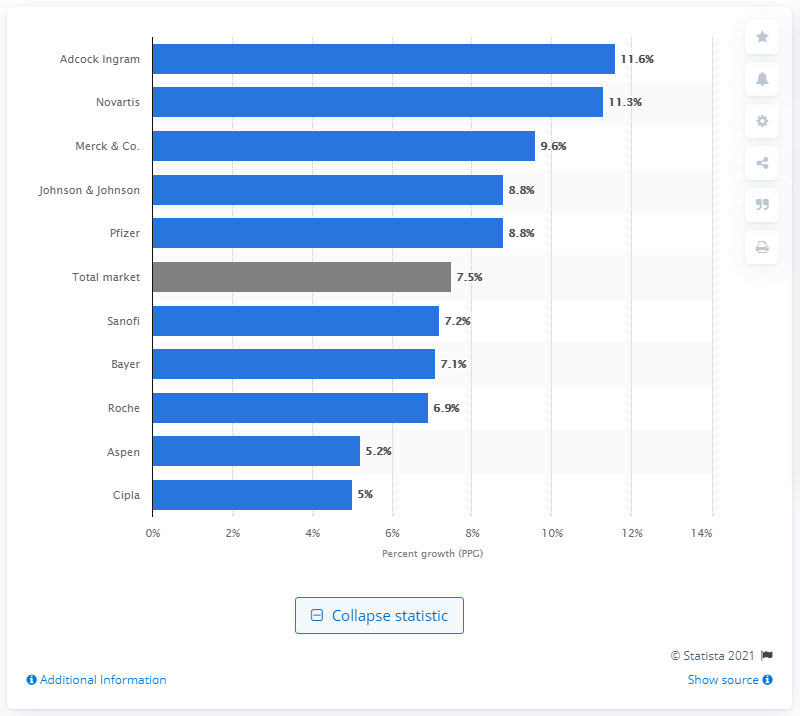Outline some significant characteristics in this image. Adcock Ingram, a South African pharmaceutical company, posted the highest growth in September 2015 compared to the previous year. 